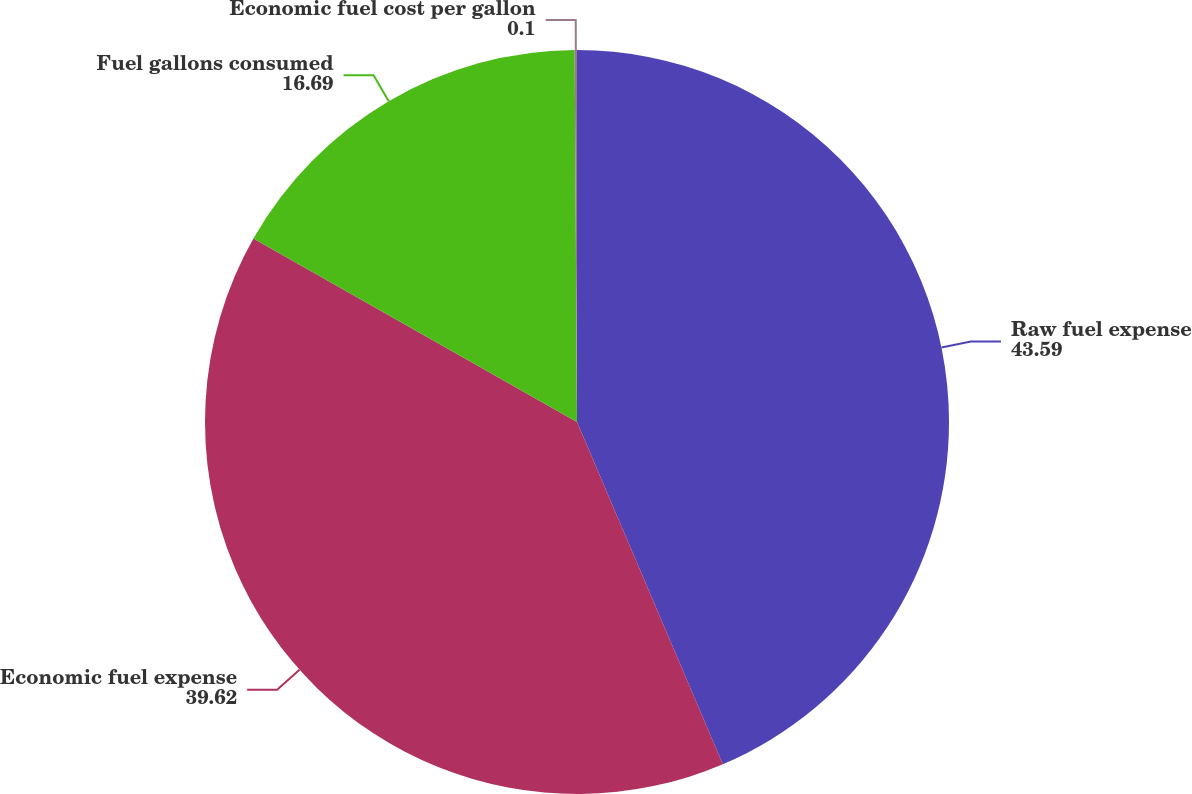<chart> <loc_0><loc_0><loc_500><loc_500><pie_chart><fcel>Raw fuel expense<fcel>Economic fuel expense<fcel>Fuel gallons consumed<fcel>Economic fuel cost per gallon<nl><fcel>43.59%<fcel>39.62%<fcel>16.69%<fcel>0.1%<nl></chart> 